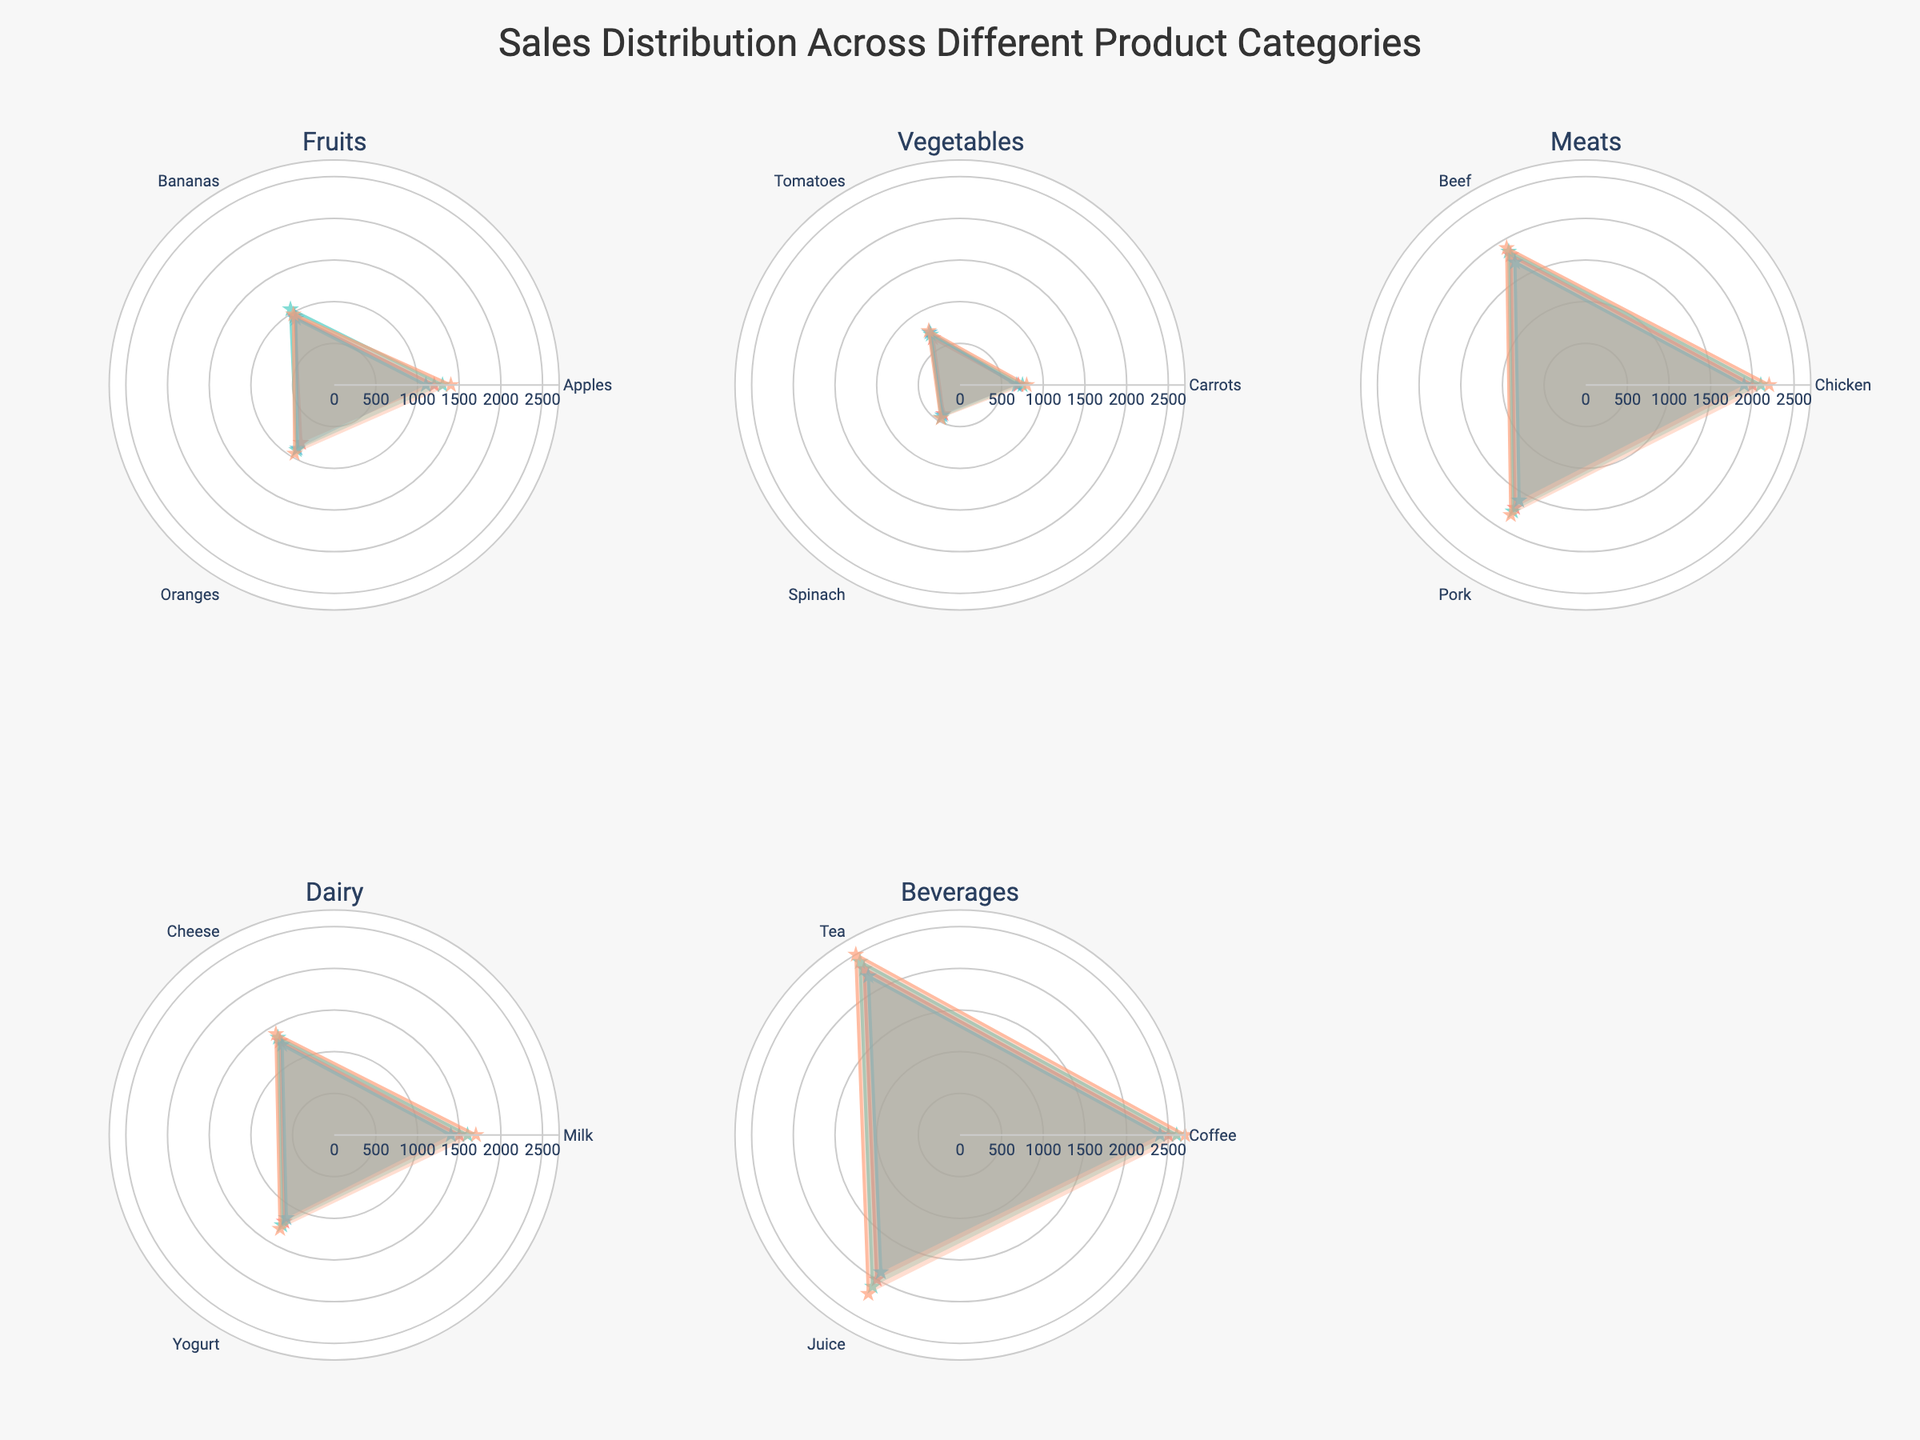What is the title of the radar chart? The title is located at the top center of the radar chart, indicating its content.
Answer: Sales Distribution Across Different Product Categories Which quarter shows the highest sales for Dairy products? Look for the Dairy subplot and compare the highest radial point across all quarters for Dairy products (Q1, Q2, Q3, Q4).
Answer: Q4 What is the sales difference between Q4 and Q3 for Coffee? Identify the sales points for Coffee in Q4 and Q3 within the Beverages subplot, then subtract Q3 sales from Q4 sales.
Answer: 300 Which product category had the highest sales overall in Q1? Identify the highest radial point in each subplot for Q1 and compare these points across all categories.
Answer: Beverages How does the trend of Apple's sales across the quarters compare within Fruits? Examine the radial points for Apples across the quarters (Q1 to Q4) in the Fruits subplot and observe whether they increase, decrease, or fluctuate.
Answer: Increase In which quarter did Vegetables - Spinach have its lowest sales? Locate the sales points for Spinach in each quarter within the Vegetables subplot and identify the lowest point.
Answer: Q1 Which quarter shows the most even distribution of sales among all products in the Meats category? Compare the radial points in the Meats subplot for each quarter to see which quarter has sales values that are closest to each other.
Answer: Q3 What is the combined sales for Oranges across all quarters? Sum the radial points for Oranges in Q1, Q2, Q3, and Q4 within the Fruits subplot.
Answer: 3530 Which product had the highest sales variation across the quarters in the Dairy category? Compare the fluctuation in radial points among Milk, Cheese, and Yogurt within the Dairy subplot to determine which has the widest sales range.
Answer: Milk 